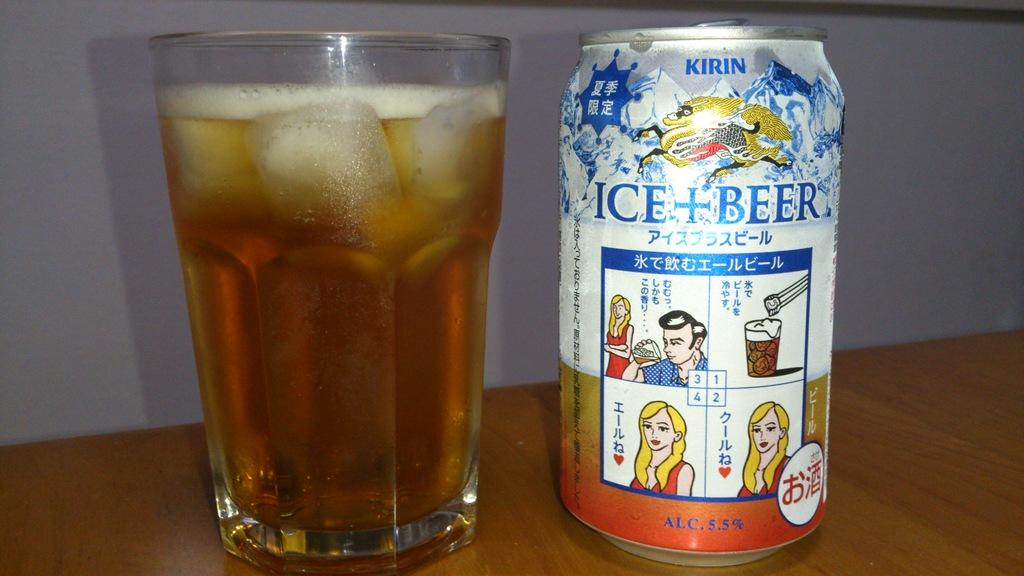<image>
Share a concise interpretation of the image provided. an ice and beer can next to a cup 